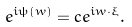<formula> <loc_0><loc_0><loc_500><loc_500>e ^ { i \psi ( w ) } = c e ^ { i w \cdot \xi } .</formula> 